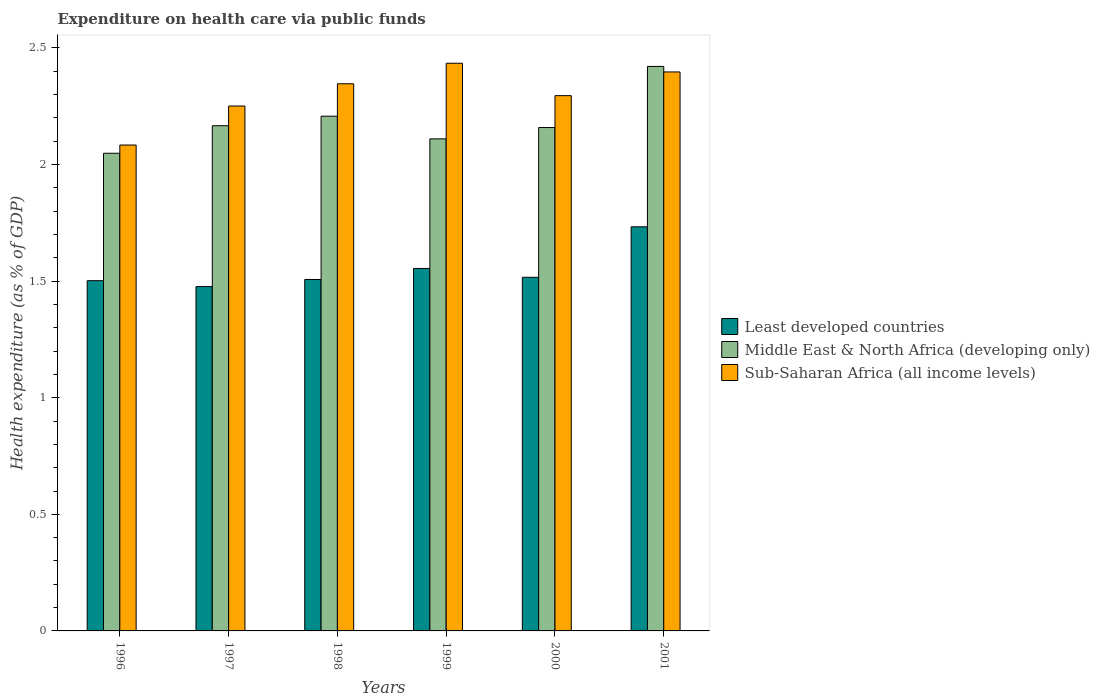How many bars are there on the 6th tick from the right?
Your answer should be very brief. 3. What is the label of the 2nd group of bars from the left?
Offer a terse response. 1997. What is the expenditure made on health care in Sub-Saharan Africa (all income levels) in 1998?
Give a very brief answer. 2.35. Across all years, what is the maximum expenditure made on health care in Middle East & North Africa (developing only)?
Offer a terse response. 2.42. Across all years, what is the minimum expenditure made on health care in Middle East & North Africa (developing only)?
Your response must be concise. 2.05. In which year was the expenditure made on health care in Middle East & North Africa (developing only) maximum?
Your response must be concise. 2001. What is the total expenditure made on health care in Sub-Saharan Africa (all income levels) in the graph?
Your response must be concise. 13.81. What is the difference between the expenditure made on health care in Least developed countries in 1996 and that in 2000?
Provide a succinct answer. -0.01. What is the difference between the expenditure made on health care in Sub-Saharan Africa (all income levels) in 2000 and the expenditure made on health care in Middle East & North Africa (developing only) in 1999?
Provide a short and direct response. 0.19. What is the average expenditure made on health care in Middle East & North Africa (developing only) per year?
Offer a terse response. 2.19. In the year 2001, what is the difference between the expenditure made on health care in Middle East & North Africa (developing only) and expenditure made on health care in Sub-Saharan Africa (all income levels)?
Ensure brevity in your answer.  0.02. What is the ratio of the expenditure made on health care in Sub-Saharan Africa (all income levels) in 1997 to that in 1999?
Your answer should be very brief. 0.92. Is the expenditure made on health care in Sub-Saharan Africa (all income levels) in 1996 less than that in 2000?
Give a very brief answer. Yes. What is the difference between the highest and the second highest expenditure made on health care in Middle East & North Africa (developing only)?
Offer a terse response. 0.21. What is the difference between the highest and the lowest expenditure made on health care in Middle East & North Africa (developing only)?
Ensure brevity in your answer.  0.37. In how many years, is the expenditure made on health care in Middle East & North Africa (developing only) greater than the average expenditure made on health care in Middle East & North Africa (developing only) taken over all years?
Offer a very short reply. 2. Is the sum of the expenditure made on health care in Middle East & North Africa (developing only) in 1997 and 2001 greater than the maximum expenditure made on health care in Sub-Saharan Africa (all income levels) across all years?
Provide a succinct answer. Yes. What does the 1st bar from the left in 1998 represents?
Your answer should be very brief. Least developed countries. What does the 2nd bar from the right in 1999 represents?
Your answer should be very brief. Middle East & North Africa (developing only). How many bars are there?
Keep it short and to the point. 18. Are all the bars in the graph horizontal?
Offer a terse response. No. What is the difference between two consecutive major ticks on the Y-axis?
Offer a terse response. 0.5. Where does the legend appear in the graph?
Your response must be concise. Center right. How many legend labels are there?
Make the answer very short. 3. What is the title of the graph?
Provide a succinct answer. Expenditure on health care via public funds. Does "Nigeria" appear as one of the legend labels in the graph?
Ensure brevity in your answer.  No. What is the label or title of the X-axis?
Offer a very short reply. Years. What is the label or title of the Y-axis?
Ensure brevity in your answer.  Health expenditure (as % of GDP). What is the Health expenditure (as % of GDP) in Least developed countries in 1996?
Offer a very short reply. 1.5. What is the Health expenditure (as % of GDP) of Middle East & North Africa (developing only) in 1996?
Ensure brevity in your answer.  2.05. What is the Health expenditure (as % of GDP) of Sub-Saharan Africa (all income levels) in 1996?
Offer a terse response. 2.08. What is the Health expenditure (as % of GDP) in Least developed countries in 1997?
Offer a very short reply. 1.48. What is the Health expenditure (as % of GDP) in Middle East & North Africa (developing only) in 1997?
Your answer should be very brief. 2.17. What is the Health expenditure (as % of GDP) in Sub-Saharan Africa (all income levels) in 1997?
Keep it short and to the point. 2.25. What is the Health expenditure (as % of GDP) of Least developed countries in 1998?
Provide a succinct answer. 1.51. What is the Health expenditure (as % of GDP) in Middle East & North Africa (developing only) in 1998?
Your response must be concise. 2.21. What is the Health expenditure (as % of GDP) in Sub-Saharan Africa (all income levels) in 1998?
Your response must be concise. 2.35. What is the Health expenditure (as % of GDP) of Least developed countries in 1999?
Your response must be concise. 1.55. What is the Health expenditure (as % of GDP) of Middle East & North Africa (developing only) in 1999?
Keep it short and to the point. 2.11. What is the Health expenditure (as % of GDP) in Sub-Saharan Africa (all income levels) in 1999?
Ensure brevity in your answer.  2.43. What is the Health expenditure (as % of GDP) of Least developed countries in 2000?
Ensure brevity in your answer.  1.52. What is the Health expenditure (as % of GDP) of Middle East & North Africa (developing only) in 2000?
Your response must be concise. 2.16. What is the Health expenditure (as % of GDP) of Sub-Saharan Africa (all income levels) in 2000?
Provide a succinct answer. 2.3. What is the Health expenditure (as % of GDP) of Least developed countries in 2001?
Your response must be concise. 1.73. What is the Health expenditure (as % of GDP) of Middle East & North Africa (developing only) in 2001?
Your answer should be very brief. 2.42. What is the Health expenditure (as % of GDP) in Sub-Saharan Africa (all income levels) in 2001?
Offer a terse response. 2.4. Across all years, what is the maximum Health expenditure (as % of GDP) of Least developed countries?
Your answer should be compact. 1.73. Across all years, what is the maximum Health expenditure (as % of GDP) of Middle East & North Africa (developing only)?
Keep it short and to the point. 2.42. Across all years, what is the maximum Health expenditure (as % of GDP) in Sub-Saharan Africa (all income levels)?
Provide a short and direct response. 2.43. Across all years, what is the minimum Health expenditure (as % of GDP) of Least developed countries?
Give a very brief answer. 1.48. Across all years, what is the minimum Health expenditure (as % of GDP) in Middle East & North Africa (developing only)?
Offer a very short reply. 2.05. Across all years, what is the minimum Health expenditure (as % of GDP) in Sub-Saharan Africa (all income levels)?
Offer a terse response. 2.08. What is the total Health expenditure (as % of GDP) of Least developed countries in the graph?
Provide a short and direct response. 9.29. What is the total Health expenditure (as % of GDP) in Middle East & North Africa (developing only) in the graph?
Give a very brief answer. 13.11. What is the total Health expenditure (as % of GDP) in Sub-Saharan Africa (all income levels) in the graph?
Your answer should be very brief. 13.81. What is the difference between the Health expenditure (as % of GDP) of Least developed countries in 1996 and that in 1997?
Your answer should be very brief. 0.03. What is the difference between the Health expenditure (as % of GDP) in Middle East & North Africa (developing only) in 1996 and that in 1997?
Your answer should be compact. -0.12. What is the difference between the Health expenditure (as % of GDP) of Sub-Saharan Africa (all income levels) in 1996 and that in 1997?
Your answer should be compact. -0.17. What is the difference between the Health expenditure (as % of GDP) in Least developed countries in 1996 and that in 1998?
Keep it short and to the point. -0.01. What is the difference between the Health expenditure (as % of GDP) in Middle East & North Africa (developing only) in 1996 and that in 1998?
Give a very brief answer. -0.16. What is the difference between the Health expenditure (as % of GDP) of Sub-Saharan Africa (all income levels) in 1996 and that in 1998?
Your response must be concise. -0.26. What is the difference between the Health expenditure (as % of GDP) in Least developed countries in 1996 and that in 1999?
Provide a short and direct response. -0.05. What is the difference between the Health expenditure (as % of GDP) in Middle East & North Africa (developing only) in 1996 and that in 1999?
Make the answer very short. -0.06. What is the difference between the Health expenditure (as % of GDP) in Sub-Saharan Africa (all income levels) in 1996 and that in 1999?
Keep it short and to the point. -0.35. What is the difference between the Health expenditure (as % of GDP) of Least developed countries in 1996 and that in 2000?
Provide a short and direct response. -0.01. What is the difference between the Health expenditure (as % of GDP) of Middle East & North Africa (developing only) in 1996 and that in 2000?
Offer a terse response. -0.11. What is the difference between the Health expenditure (as % of GDP) in Sub-Saharan Africa (all income levels) in 1996 and that in 2000?
Keep it short and to the point. -0.21. What is the difference between the Health expenditure (as % of GDP) of Least developed countries in 1996 and that in 2001?
Keep it short and to the point. -0.23. What is the difference between the Health expenditure (as % of GDP) in Middle East & North Africa (developing only) in 1996 and that in 2001?
Provide a short and direct response. -0.37. What is the difference between the Health expenditure (as % of GDP) in Sub-Saharan Africa (all income levels) in 1996 and that in 2001?
Provide a succinct answer. -0.31. What is the difference between the Health expenditure (as % of GDP) in Least developed countries in 1997 and that in 1998?
Your response must be concise. -0.03. What is the difference between the Health expenditure (as % of GDP) in Middle East & North Africa (developing only) in 1997 and that in 1998?
Give a very brief answer. -0.04. What is the difference between the Health expenditure (as % of GDP) in Sub-Saharan Africa (all income levels) in 1997 and that in 1998?
Your answer should be very brief. -0.1. What is the difference between the Health expenditure (as % of GDP) in Least developed countries in 1997 and that in 1999?
Ensure brevity in your answer.  -0.08. What is the difference between the Health expenditure (as % of GDP) in Middle East & North Africa (developing only) in 1997 and that in 1999?
Provide a succinct answer. 0.06. What is the difference between the Health expenditure (as % of GDP) of Sub-Saharan Africa (all income levels) in 1997 and that in 1999?
Make the answer very short. -0.18. What is the difference between the Health expenditure (as % of GDP) of Least developed countries in 1997 and that in 2000?
Your response must be concise. -0.04. What is the difference between the Health expenditure (as % of GDP) of Middle East & North Africa (developing only) in 1997 and that in 2000?
Your answer should be very brief. 0.01. What is the difference between the Health expenditure (as % of GDP) in Sub-Saharan Africa (all income levels) in 1997 and that in 2000?
Your answer should be compact. -0.04. What is the difference between the Health expenditure (as % of GDP) in Least developed countries in 1997 and that in 2001?
Your answer should be compact. -0.26. What is the difference between the Health expenditure (as % of GDP) in Middle East & North Africa (developing only) in 1997 and that in 2001?
Your response must be concise. -0.25. What is the difference between the Health expenditure (as % of GDP) of Sub-Saharan Africa (all income levels) in 1997 and that in 2001?
Give a very brief answer. -0.15. What is the difference between the Health expenditure (as % of GDP) in Least developed countries in 1998 and that in 1999?
Provide a short and direct response. -0.05. What is the difference between the Health expenditure (as % of GDP) in Middle East & North Africa (developing only) in 1998 and that in 1999?
Your response must be concise. 0.1. What is the difference between the Health expenditure (as % of GDP) of Sub-Saharan Africa (all income levels) in 1998 and that in 1999?
Offer a terse response. -0.09. What is the difference between the Health expenditure (as % of GDP) of Least developed countries in 1998 and that in 2000?
Make the answer very short. -0.01. What is the difference between the Health expenditure (as % of GDP) of Middle East & North Africa (developing only) in 1998 and that in 2000?
Keep it short and to the point. 0.05. What is the difference between the Health expenditure (as % of GDP) of Sub-Saharan Africa (all income levels) in 1998 and that in 2000?
Offer a very short reply. 0.05. What is the difference between the Health expenditure (as % of GDP) in Least developed countries in 1998 and that in 2001?
Provide a short and direct response. -0.23. What is the difference between the Health expenditure (as % of GDP) in Middle East & North Africa (developing only) in 1998 and that in 2001?
Your answer should be compact. -0.21. What is the difference between the Health expenditure (as % of GDP) of Sub-Saharan Africa (all income levels) in 1998 and that in 2001?
Your response must be concise. -0.05. What is the difference between the Health expenditure (as % of GDP) of Least developed countries in 1999 and that in 2000?
Your answer should be very brief. 0.04. What is the difference between the Health expenditure (as % of GDP) of Middle East & North Africa (developing only) in 1999 and that in 2000?
Your answer should be compact. -0.05. What is the difference between the Health expenditure (as % of GDP) of Sub-Saharan Africa (all income levels) in 1999 and that in 2000?
Provide a succinct answer. 0.14. What is the difference between the Health expenditure (as % of GDP) in Least developed countries in 1999 and that in 2001?
Offer a terse response. -0.18. What is the difference between the Health expenditure (as % of GDP) of Middle East & North Africa (developing only) in 1999 and that in 2001?
Provide a short and direct response. -0.31. What is the difference between the Health expenditure (as % of GDP) of Sub-Saharan Africa (all income levels) in 1999 and that in 2001?
Make the answer very short. 0.04. What is the difference between the Health expenditure (as % of GDP) in Least developed countries in 2000 and that in 2001?
Provide a short and direct response. -0.22. What is the difference between the Health expenditure (as % of GDP) of Middle East & North Africa (developing only) in 2000 and that in 2001?
Give a very brief answer. -0.26. What is the difference between the Health expenditure (as % of GDP) of Sub-Saharan Africa (all income levels) in 2000 and that in 2001?
Your response must be concise. -0.1. What is the difference between the Health expenditure (as % of GDP) of Least developed countries in 1996 and the Health expenditure (as % of GDP) of Middle East & North Africa (developing only) in 1997?
Your answer should be compact. -0.66. What is the difference between the Health expenditure (as % of GDP) of Least developed countries in 1996 and the Health expenditure (as % of GDP) of Sub-Saharan Africa (all income levels) in 1997?
Offer a terse response. -0.75. What is the difference between the Health expenditure (as % of GDP) of Middle East & North Africa (developing only) in 1996 and the Health expenditure (as % of GDP) of Sub-Saharan Africa (all income levels) in 1997?
Make the answer very short. -0.2. What is the difference between the Health expenditure (as % of GDP) in Least developed countries in 1996 and the Health expenditure (as % of GDP) in Middle East & North Africa (developing only) in 1998?
Offer a terse response. -0.71. What is the difference between the Health expenditure (as % of GDP) in Least developed countries in 1996 and the Health expenditure (as % of GDP) in Sub-Saharan Africa (all income levels) in 1998?
Your answer should be compact. -0.84. What is the difference between the Health expenditure (as % of GDP) in Middle East & North Africa (developing only) in 1996 and the Health expenditure (as % of GDP) in Sub-Saharan Africa (all income levels) in 1998?
Your answer should be very brief. -0.3. What is the difference between the Health expenditure (as % of GDP) in Least developed countries in 1996 and the Health expenditure (as % of GDP) in Middle East & North Africa (developing only) in 1999?
Give a very brief answer. -0.61. What is the difference between the Health expenditure (as % of GDP) of Least developed countries in 1996 and the Health expenditure (as % of GDP) of Sub-Saharan Africa (all income levels) in 1999?
Provide a short and direct response. -0.93. What is the difference between the Health expenditure (as % of GDP) in Middle East & North Africa (developing only) in 1996 and the Health expenditure (as % of GDP) in Sub-Saharan Africa (all income levels) in 1999?
Keep it short and to the point. -0.39. What is the difference between the Health expenditure (as % of GDP) of Least developed countries in 1996 and the Health expenditure (as % of GDP) of Middle East & North Africa (developing only) in 2000?
Your answer should be very brief. -0.66. What is the difference between the Health expenditure (as % of GDP) of Least developed countries in 1996 and the Health expenditure (as % of GDP) of Sub-Saharan Africa (all income levels) in 2000?
Give a very brief answer. -0.79. What is the difference between the Health expenditure (as % of GDP) in Middle East & North Africa (developing only) in 1996 and the Health expenditure (as % of GDP) in Sub-Saharan Africa (all income levels) in 2000?
Your response must be concise. -0.25. What is the difference between the Health expenditure (as % of GDP) of Least developed countries in 1996 and the Health expenditure (as % of GDP) of Middle East & North Africa (developing only) in 2001?
Keep it short and to the point. -0.92. What is the difference between the Health expenditure (as % of GDP) of Least developed countries in 1996 and the Health expenditure (as % of GDP) of Sub-Saharan Africa (all income levels) in 2001?
Your response must be concise. -0.9. What is the difference between the Health expenditure (as % of GDP) in Middle East & North Africa (developing only) in 1996 and the Health expenditure (as % of GDP) in Sub-Saharan Africa (all income levels) in 2001?
Your response must be concise. -0.35. What is the difference between the Health expenditure (as % of GDP) in Least developed countries in 1997 and the Health expenditure (as % of GDP) in Middle East & North Africa (developing only) in 1998?
Give a very brief answer. -0.73. What is the difference between the Health expenditure (as % of GDP) in Least developed countries in 1997 and the Health expenditure (as % of GDP) in Sub-Saharan Africa (all income levels) in 1998?
Make the answer very short. -0.87. What is the difference between the Health expenditure (as % of GDP) of Middle East & North Africa (developing only) in 1997 and the Health expenditure (as % of GDP) of Sub-Saharan Africa (all income levels) in 1998?
Provide a short and direct response. -0.18. What is the difference between the Health expenditure (as % of GDP) in Least developed countries in 1997 and the Health expenditure (as % of GDP) in Middle East & North Africa (developing only) in 1999?
Your answer should be compact. -0.63. What is the difference between the Health expenditure (as % of GDP) in Least developed countries in 1997 and the Health expenditure (as % of GDP) in Sub-Saharan Africa (all income levels) in 1999?
Your answer should be compact. -0.96. What is the difference between the Health expenditure (as % of GDP) in Middle East & North Africa (developing only) in 1997 and the Health expenditure (as % of GDP) in Sub-Saharan Africa (all income levels) in 1999?
Offer a very short reply. -0.27. What is the difference between the Health expenditure (as % of GDP) of Least developed countries in 1997 and the Health expenditure (as % of GDP) of Middle East & North Africa (developing only) in 2000?
Offer a very short reply. -0.68. What is the difference between the Health expenditure (as % of GDP) in Least developed countries in 1997 and the Health expenditure (as % of GDP) in Sub-Saharan Africa (all income levels) in 2000?
Provide a short and direct response. -0.82. What is the difference between the Health expenditure (as % of GDP) of Middle East & North Africa (developing only) in 1997 and the Health expenditure (as % of GDP) of Sub-Saharan Africa (all income levels) in 2000?
Make the answer very short. -0.13. What is the difference between the Health expenditure (as % of GDP) in Least developed countries in 1997 and the Health expenditure (as % of GDP) in Middle East & North Africa (developing only) in 2001?
Your answer should be compact. -0.94. What is the difference between the Health expenditure (as % of GDP) of Least developed countries in 1997 and the Health expenditure (as % of GDP) of Sub-Saharan Africa (all income levels) in 2001?
Give a very brief answer. -0.92. What is the difference between the Health expenditure (as % of GDP) in Middle East & North Africa (developing only) in 1997 and the Health expenditure (as % of GDP) in Sub-Saharan Africa (all income levels) in 2001?
Your answer should be compact. -0.23. What is the difference between the Health expenditure (as % of GDP) in Least developed countries in 1998 and the Health expenditure (as % of GDP) in Middle East & North Africa (developing only) in 1999?
Your answer should be very brief. -0.6. What is the difference between the Health expenditure (as % of GDP) of Least developed countries in 1998 and the Health expenditure (as % of GDP) of Sub-Saharan Africa (all income levels) in 1999?
Provide a short and direct response. -0.93. What is the difference between the Health expenditure (as % of GDP) of Middle East & North Africa (developing only) in 1998 and the Health expenditure (as % of GDP) of Sub-Saharan Africa (all income levels) in 1999?
Keep it short and to the point. -0.23. What is the difference between the Health expenditure (as % of GDP) in Least developed countries in 1998 and the Health expenditure (as % of GDP) in Middle East & North Africa (developing only) in 2000?
Offer a very short reply. -0.65. What is the difference between the Health expenditure (as % of GDP) in Least developed countries in 1998 and the Health expenditure (as % of GDP) in Sub-Saharan Africa (all income levels) in 2000?
Provide a short and direct response. -0.79. What is the difference between the Health expenditure (as % of GDP) of Middle East & North Africa (developing only) in 1998 and the Health expenditure (as % of GDP) of Sub-Saharan Africa (all income levels) in 2000?
Offer a terse response. -0.09. What is the difference between the Health expenditure (as % of GDP) in Least developed countries in 1998 and the Health expenditure (as % of GDP) in Middle East & North Africa (developing only) in 2001?
Your response must be concise. -0.91. What is the difference between the Health expenditure (as % of GDP) in Least developed countries in 1998 and the Health expenditure (as % of GDP) in Sub-Saharan Africa (all income levels) in 2001?
Make the answer very short. -0.89. What is the difference between the Health expenditure (as % of GDP) of Middle East & North Africa (developing only) in 1998 and the Health expenditure (as % of GDP) of Sub-Saharan Africa (all income levels) in 2001?
Offer a very short reply. -0.19. What is the difference between the Health expenditure (as % of GDP) of Least developed countries in 1999 and the Health expenditure (as % of GDP) of Middle East & North Africa (developing only) in 2000?
Your answer should be very brief. -0.6. What is the difference between the Health expenditure (as % of GDP) in Least developed countries in 1999 and the Health expenditure (as % of GDP) in Sub-Saharan Africa (all income levels) in 2000?
Give a very brief answer. -0.74. What is the difference between the Health expenditure (as % of GDP) in Middle East & North Africa (developing only) in 1999 and the Health expenditure (as % of GDP) in Sub-Saharan Africa (all income levels) in 2000?
Your response must be concise. -0.19. What is the difference between the Health expenditure (as % of GDP) of Least developed countries in 1999 and the Health expenditure (as % of GDP) of Middle East & North Africa (developing only) in 2001?
Your answer should be very brief. -0.87. What is the difference between the Health expenditure (as % of GDP) of Least developed countries in 1999 and the Health expenditure (as % of GDP) of Sub-Saharan Africa (all income levels) in 2001?
Your answer should be compact. -0.84. What is the difference between the Health expenditure (as % of GDP) of Middle East & North Africa (developing only) in 1999 and the Health expenditure (as % of GDP) of Sub-Saharan Africa (all income levels) in 2001?
Ensure brevity in your answer.  -0.29. What is the difference between the Health expenditure (as % of GDP) in Least developed countries in 2000 and the Health expenditure (as % of GDP) in Middle East & North Africa (developing only) in 2001?
Ensure brevity in your answer.  -0.9. What is the difference between the Health expenditure (as % of GDP) of Least developed countries in 2000 and the Health expenditure (as % of GDP) of Sub-Saharan Africa (all income levels) in 2001?
Offer a very short reply. -0.88. What is the difference between the Health expenditure (as % of GDP) of Middle East & North Africa (developing only) in 2000 and the Health expenditure (as % of GDP) of Sub-Saharan Africa (all income levels) in 2001?
Your answer should be compact. -0.24. What is the average Health expenditure (as % of GDP) of Least developed countries per year?
Keep it short and to the point. 1.55. What is the average Health expenditure (as % of GDP) of Middle East & North Africa (developing only) per year?
Offer a very short reply. 2.19. What is the average Health expenditure (as % of GDP) of Sub-Saharan Africa (all income levels) per year?
Offer a very short reply. 2.3. In the year 1996, what is the difference between the Health expenditure (as % of GDP) in Least developed countries and Health expenditure (as % of GDP) in Middle East & North Africa (developing only)?
Give a very brief answer. -0.55. In the year 1996, what is the difference between the Health expenditure (as % of GDP) of Least developed countries and Health expenditure (as % of GDP) of Sub-Saharan Africa (all income levels)?
Make the answer very short. -0.58. In the year 1996, what is the difference between the Health expenditure (as % of GDP) in Middle East & North Africa (developing only) and Health expenditure (as % of GDP) in Sub-Saharan Africa (all income levels)?
Your answer should be very brief. -0.04. In the year 1997, what is the difference between the Health expenditure (as % of GDP) of Least developed countries and Health expenditure (as % of GDP) of Middle East & North Africa (developing only)?
Your answer should be compact. -0.69. In the year 1997, what is the difference between the Health expenditure (as % of GDP) in Least developed countries and Health expenditure (as % of GDP) in Sub-Saharan Africa (all income levels)?
Make the answer very short. -0.77. In the year 1997, what is the difference between the Health expenditure (as % of GDP) in Middle East & North Africa (developing only) and Health expenditure (as % of GDP) in Sub-Saharan Africa (all income levels)?
Give a very brief answer. -0.08. In the year 1998, what is the difference between the Health expenditure (as % of GDP) of Least developed countries and Health expenditure (as % of GDP) of Middle East & North Africa (developing only)?
Keep it short and to the point. -0.7. In the year 1998, what is the difference between the Health expenditure (as % of GDP) of Least developed countries and Health expenditure (as % of GDP) of Sub-Saharan Africa (all income levels)?
Your response must be concise. -0.84. In the year 1998, what is the difference between the Health expenditure (as % of GDP) in Middle East & North Africa (developing only) and Health expenditure (as % of GDP) in Sub-Saharan Africa (all income levels)?
Give a very brief answer. -0.14. In the year 1999, what is the difference between the Health expenditure (as % of GDP) of Least developed countries and Health expenditure (as % of GDP) of Middle East & North Africa (developing only)?
Provide a short and direct response. -0.56. In the year 1999, what is the difference between the Health expenditure (as % of GDP) of Least developed countries and Health expenditure (as % of GDP) of Sub-Saharan Africa (all income levels)?
Your response must be concise. -0.88. In the year 1999, what is the difference between the Health expenditure (as % of GDP) in Middle East & North Africa (developing only) and Health expenditure (as % of GDP) in Sub-Saharan Africa (all income levels)?
Provide a succinct answer. -0.32. In the year 2000, what is the difference between the Health expenditure (as % of GDP) of Least developed countries and Health expenditure (as % of GDP) of Middle East & North Africa (developing only)?
Offer a very short reply. -0.64. In the year 2000, what is the difference between the Health expenditure (as % of GDP) in Least developed countries and Health expenditure (as % of GDP) in Sub-Saharan Africa (all income levels)?
Ensure brevity in your answer.  -0.78. In the year 2000, what is the difference between the Health expenditure (as % of GDP) in Middle East & North Africa (developing only) and Health expenditure (as % of GDP) in Sub-Saharan Africa (all income levels)?
Make the answer very short. -0.14. In the year 2001, what is the difference between the Health expenditure (as % of GDP) of Least developed countries and Health expenditure (as % of GDP) of Middle East & North Africa (developing only)?
Ensure brevity in your answer.  -0.69. In the year 2001, what is the difference between the Health expenditure (as % of GDP) of Least developed countries and Health expenditure (as % of GDP) of Sub-Saharan Africa (all income levels)?
Your answer should be very brief. -0.66. In the year 2001, what is the difference between the Health expenditure (as % of GDP) in Middle East & North Africa (developing only) and Health expenditure (as % of GDP) in Sub-Saharan Africa (all income levels)?
Your answer should be very brief. 0.02. What is the ratio of the Health expenditure (as % of GDP) in Least developed countries in 1996 to that in 1997?
Your answer should be compact. 1.02. What is the ratio of the Health expenditure (as % of GDP) in Middle East & North Africa (developing only) in 1996 to that in 1997?
Your response must be concise. 0.95. What is the ratio of the Health expenditure (as % of GDP) in Sub-Saharan Africa (all income levels) in 1996 to that in 1997?
Give a very brief answer. 0.93. What is the ratio of the Health expenditure (as % of GDP) of Least developed countries in 1996 to that in 1998?
Offer a very short reply. 1. What is the ratio of the Health expenditure (as % of GDP) in Middle East & North Africa (developing only) in 1996 to that in 1998?
Ensure brevity in your answer.  0.93. What is the ratio of the Health expenditure (as % of GDP) of Sub-Saharan Africa (all income levels) in 1996 to that in 1998?
Your response must be concise. 0.89. What is the ratio of the Health expenditure (as % of GDP) of Least developed countries in 1996 to that in 1999?
Your response must be concise. 0.97. What is the ratio of the Health expenditure (as % of GDP) of Middle East & North Africa (developing only) in 1996 to that in 1999?
Your response must be concise. 0.97. What is the ratio of the Health expenditure (as % of GDP) of Sub-Saharan Africa (all income levels) in 1996 to that in 1999?
Your answer should be very brief. 0.86. What is the ratio of the Health expenditure (as % of GDP) of Least developed countries in 1996 to that in 2000?
Offer a terse response. 0.99. What is the ratio of the Health expenditure (as % of GDP) in Middle East & North Africa (developing only) in 1996 to that in 2000?
Give a very brief answer. 0.95. What is the ratio of the Health expenditure (as % of GDP) of Sub-Saharan Africa (all income levels) in 1996 to that in 2000?
Your answer should be very brief. 0.91. What is the ratio of the Health expenditure (as % of GDP) in Least developed countries in 1996 to that in 2001?
Your answer should be compact. 0.87. What is the ratio of the Health expenditure (as % of GDP) in Middle East & North Africa (developing only) in 1996 to that in 2001?
Provide a short and direct response. 0.85. What is the ratio of the Health expenditure (as % of GDP) of Sub-Saharan Africa (all income levels) in 1996 to that in 2001?
Offer a terse response. 0.87. What is the ratio of the Health expenditure (as % of GDP) of Least developed countries in 1997 to that in 1998?
Provide a short and direct response. 0.98. What is the ratio of the Health expenditure (as % of GDP) in Middle East & North Africa (developing only) in 1997 to that in 1998?
Keep it short and to the point. 0.98. What is the ratio of the Health expenditure (as % of GDP) in Sub-Saharan Africa (all income levels) in 1997 to that in 1998?
Provide a succinct answer. 0.96. What is the ratio of the Health expenditure (as % of GDP) in Least developed countries in 1997 to that in 1999?
Give a very brief answer. 0.95. What is the ratio of the Health expenditure (as % of GDP) of Middle East & North Africa (developing only) in 1997 to that in 1999?
Provide a short and direct response. 1.03. What is the ratio of the Health expenditure (as % of GDP) of Sub-Saharan Africa (all income levels) in 1997 to that in 1999?
Offer a very short reply. 0.92. What is the ratio of the Health expenditure (as % of GDP) of Least developed countries in 1997 to that in 2000?
Your answer should be very brief. 0.97. What is the ratio of the Health expenditure (as % of GDP) of Middle East & North Africa (developing only) in 1997 to that in 2000?
Ensure brevity in your answer.  1. What is the ratio of the Health expenditure (as % of GDP) of Sub-Saharan Africa (all income levels) in 1997 to that in 2000?
Your answer should be very brief. 0.98. What is the ratio of the Health expenditure (as % of GDP) in Least developed countries in 1997 to that in 2001?
Provide a short and direct response. 0.85. What is the ratio of the Health expenditure (as % of GDP) in Middle East & North Africa (developing only) in 1997 to that in 2001?
Provide a succinct answer. 0.9. What is the ratio of the Health expenditure (as % of GDP) of Sub-Saharan Africa (all income levels) in 1997 to that in 2001?
Offer a very short reply. 0.94. What is the ratio of the Health expenditure (as % of GDP) of Least developed countries in 1998 to that in 1999?
Provide a short and direct response. 0.97. What is the ratio of the Health expenditure (as % of GDP) of Middle East & North Africa (developing only) in 1998 to that in 1999?
Your response must be concise. 1.05. What is the ratio of the Health expenditure (as % of GDP) of Sub-Saharan Africa (all income levels) in 1998 to that in 1999?
Keep it short and to the point. 0.96. What is the ratio of the Health expenditure (as % of GDP) of Middle East & North Africa (developing only) in 1998 to that in 2000?
Provide a short and direct response. 1.02. What is the ratio of the Health expenditure (as % of GDP) of Sub-Saharan Africa (all income levels) in 1998 to that in 2000?
Offer a very short reply. 1.02. What is the ratio of the Health expenditure (as % of GDP) in Least developed countries in 1998 to that in 2001?
Your answer should be very brief. 0.87. What is the ratio of the Health expenditure (as % of GDP) of Middle East & North Africa (developing only) in 1998 to that in 2001?
Provide a succinct answer. 0.91. What is the ratio of the Health expenditure (as % of GDP) of Sub-Saharan Africa (all income levels) in 1998 to that in 2001?
Offer a very short reply. 0.98. What is the ratio of the Health expenditure (as % of GDP) in Least developed countries in 1999 to that in 2000?
Offer a very short reply. 1.02. What is the ratio of the Health expenditure (as % of GDP) in Middle East & North Africa (developing only) in 1999 to that in 2000?
Ensure brevity in your answer.  0.98. What is the ratio of the Health expenditure (as % of GDP) of Sub-Saharan Africa (all income levels) in 1999 to that in 2000?
Provide a succinct answer. 1.06. What is the ratio of the Health expenditure (as % of GDP) of Least developed countries in 1999 to that in 2001?
Make the answer very short. 0.9. What is the ratio of the Health expenditure (as % of GDP) in Middle East & North Africa (developing only) in 1999 to that in 2001?
Provide a succinct answer. 0.87. What is the ratio of the Health expenditure (as % of GDP) of Sub-Saharan Africa (all income levels) in 1999 to that in 2001?
Provide a succinct answer. 1.02. What is the ratio of the Health expenditure (as % of GDP) in Least developed countries in 2000 to that in 2001?
Provide a succinct answer. 0.88. What is the ratio of the Health expenditure (as % of GDP) of Middle East & North Africa (developing only) in 2000 to that in 2001?
Offer a terse response. 0.89. What is the ratio of the Health expenditure (as % of GDP) in Sub-Saharan Africa (all income levels) in 2000 to that in 2001?
Offer a very short reply. 0.96. What is the difference between the highest and the second highest Health expenditure (as % of GDP) in Least developed countries?
Provide a succinct answer. 0.18. What is the difference between the highest and the second highest Health expenditure (as % of GDP) of Middle East & North Africa (developing only)?
Offer a very short reply. 0.21. What is the difference between the highest and the second highest Health expenditure (as % of GDP) in Sub-Saharan Africa (all income levels)?
Ensure brevity in your answer.  0.04. What is the difference between the highest and the lowest Health expenditure (as % of GDP) of Least developed countries?
Your response must be concise. 0.26. What is the difference between the highest and the lowest Health expenditure (as % of GDP) of Middle East & North Africa (developing only)?
Make the answer very short. 0.37. What is the difference between the highest and the lowest Health expenditure (as % of GDP) in Sub-Saharan Africa (all income levels)?
Provide a short and direct response. 0.35. 